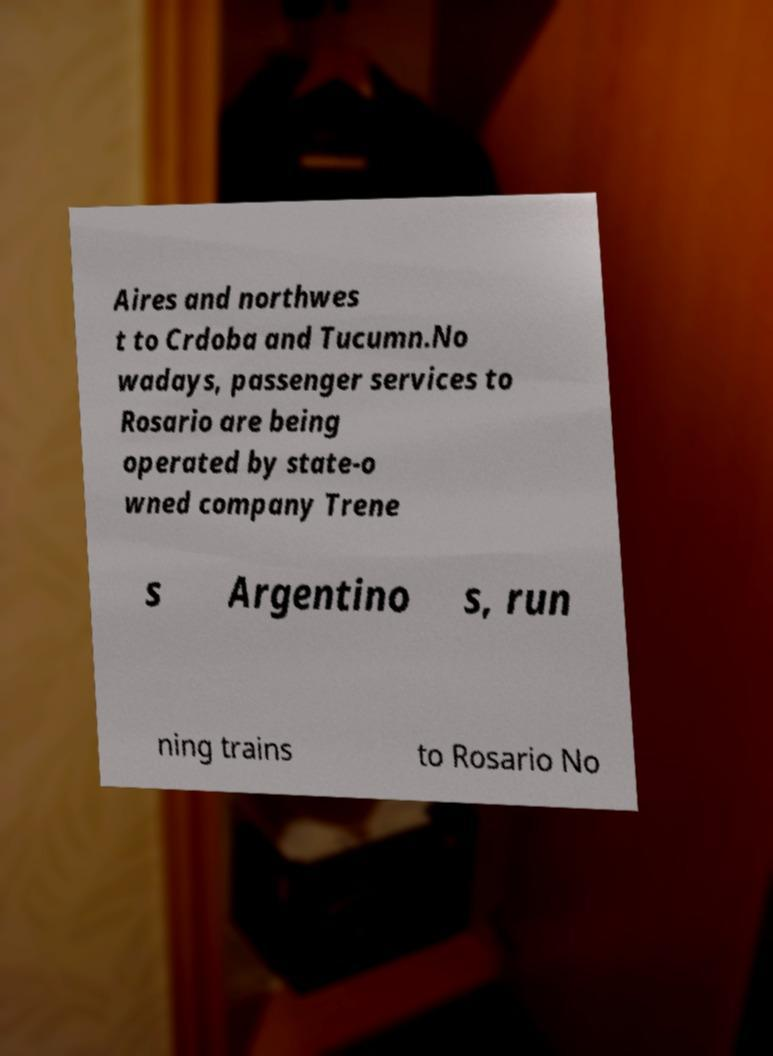For documentation purposes, I need the text within this image transcribed. Could you provide that? Aires and northwes t to Crdoba and Tucumn.No wadays, passenger services to Rosario are being operated by state-o wned company Trene s Argentino s, run ning trains to Rosario No 